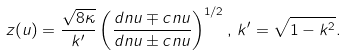<formula> <loc_0><loc_0><loc_500><loc_500>z ( u ) = \frac { \sqrt { 8 \kappa } } { k ^ { \prime } } \left ( \frac { d n u \mp c n u } { d n u \pm c n u } \right ) ^ { 1 / 2 } , \, k ^ { \prime } = \sqrt { 1 - k ^ { 2 } } .</formula> 